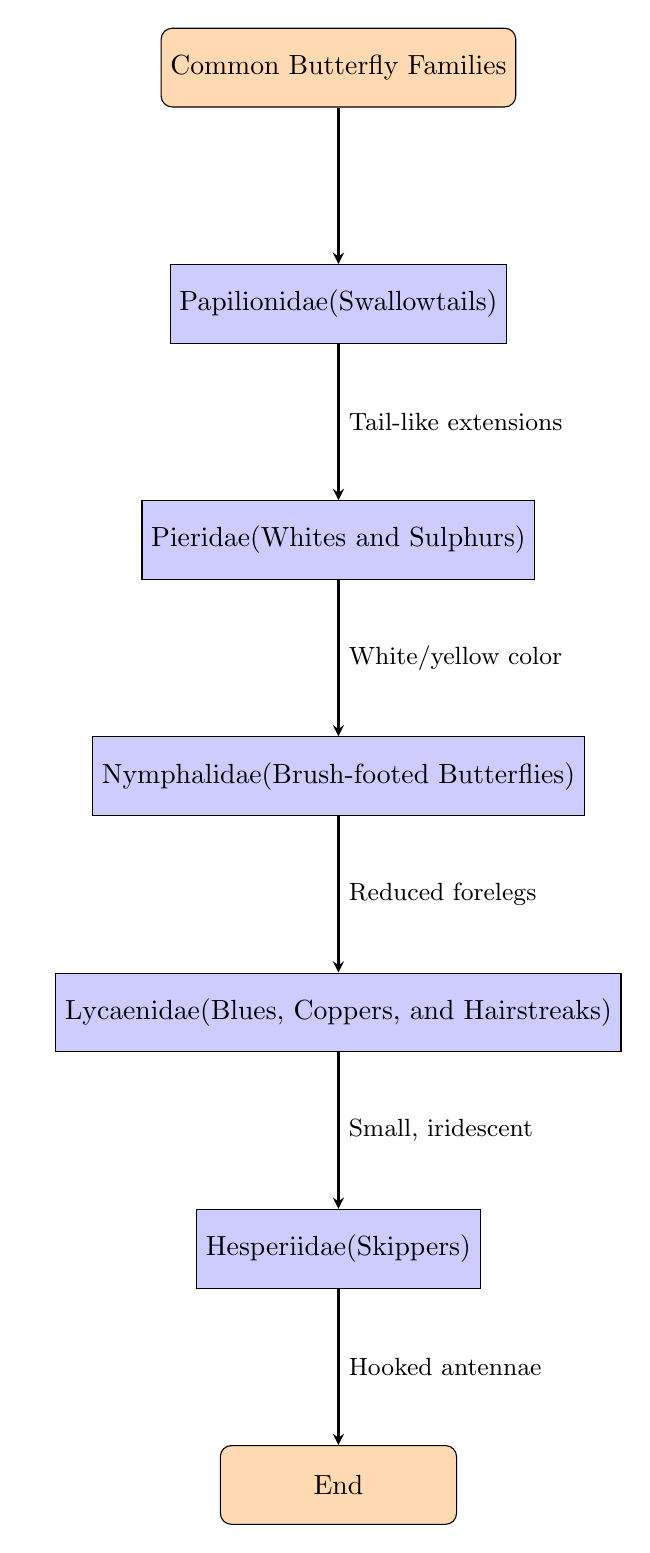What is the first node in the flowchart? The first node in the flowchart represents the starting point of the classification, which is "Common Butterfly Families".
Answer: Common Butterfly Families How many butterfly families are represented in the flowchart? The flowchart contains five butterfly families, each represented by a separate node.
Answer: 5 What is the condition that leads to the classification of Papilionidae? The condition for classifying Papilionidae is the "Presence of tail-like extensions on hindwings".
Answer: Presence of tail-like extensions on hindwings What family follows Pieridae in the classification flow? The family that follows Pieridae is Nymphalidae, which is indicated by the direction of the arrow from node 2 to node 3.
Answer: Nymphalidae What unique feature characterizes Hesperiidae according to this diagram? Hesperiidae is characterized by "Hooked antennae and rapid, skipping flight", which is the condition leading from node 5 to the end of the flowchart.
Answer: Hooked antennae and rapid, skipping flight Which butterfly family is associated with reduced forelegs? The butterfly family associated with reduced forelegs is Nymphalidae, as shown in the diagram with an arrow connecting node 3 to node 4 and the condition noted beside it.
Answer: Nymphalidae Which node comes after Lycaenidae? The node that comes after Lycaenidae is Hesperiidae, as seen by the arrow pointing from node 4 to node 5.
Answer: Hesperiidae Identify the color characteristic associated with Pieridae. The color characteristic associated with Pieridae is typically "bright white or yellow coloration", which is the condition leading from node 2 to node 3.
Answer: bright white or yellow coloration What is the common feature of butterflies classified under Papilionidae? The common feature of butterflies classified under Papilionidae is the "Presence of tail-like extensions on hindwings."
Answer: Presence of tail-like extensions on hindwings 